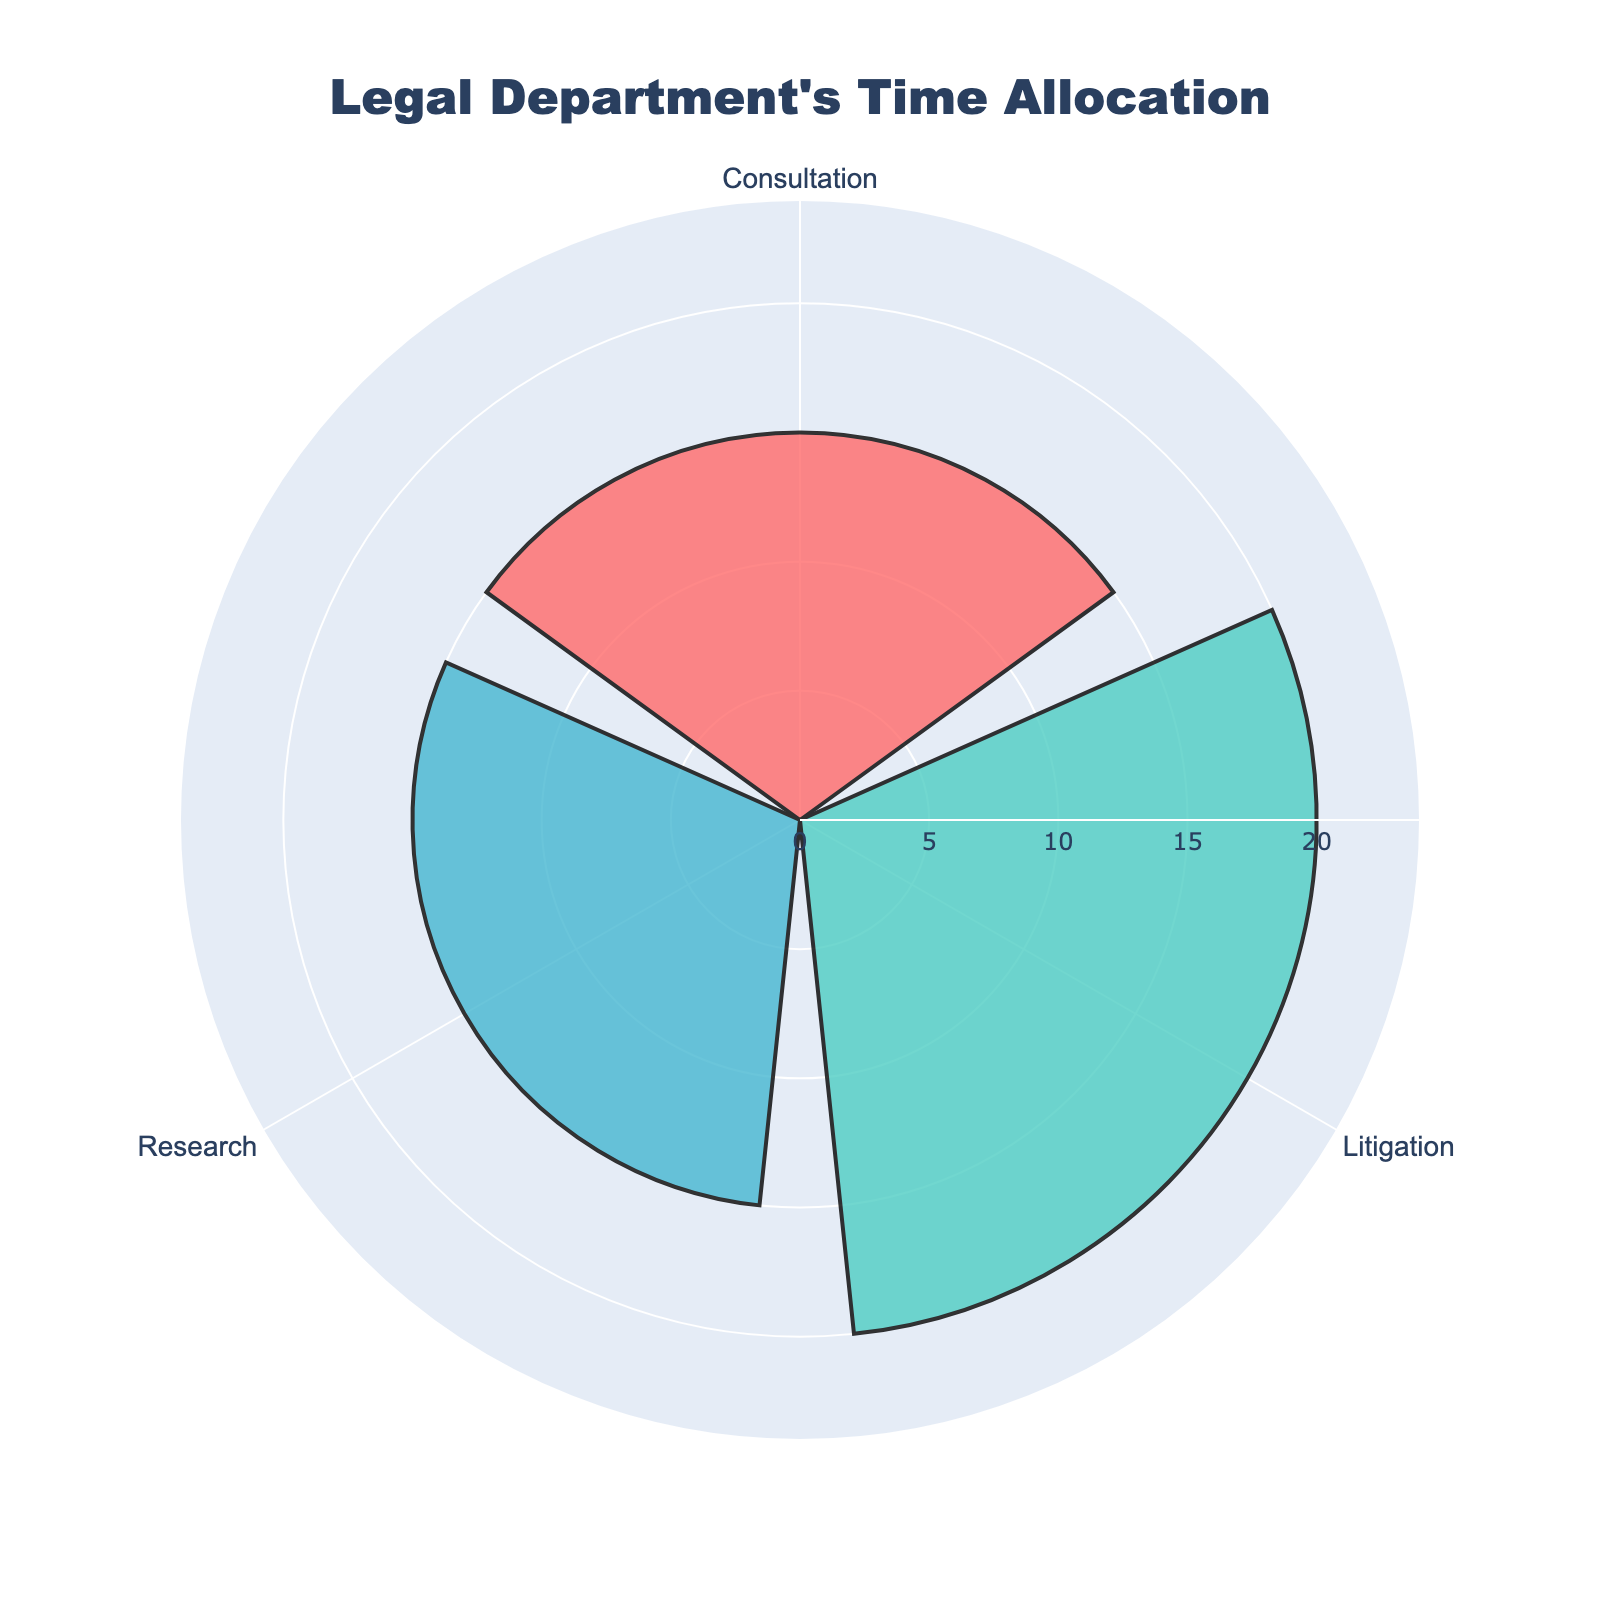What's the title of the figure? The title of the figure is prominently displayed at the top, directly above the rose chart.
Answer: Legal Department's Time Allocation How many activities are represented in the figure? Each activity is labeled around the chart, making the total number of activities easy to count.
Answer: 3 Which activity takes up the most time in a week? By comparing the lengths of the bars, you can see which one extends the furthest from the center. The longest bar represents the activity with the highest time allocation.
Answer: Litigation How much time is spent on Consultation per week? The "Consultation" bar represents the combined time from both types of consultations (10 + 5). Look at the length of the "Consultation" bar and find the number indicated on the radial axis.
Answer: 15 hours Compare the time spent on Research and Litigation. Which one is greater, and by how much? By comparing the lengths of the bars for "Research" and "Litigation," you can see which one is longer and then calculate the difference in their lengths.
Answer: Litigation is greater by 5 hours What is the total time allocated for all activities per week? Add the values of all bars: Research (15), Consultation (15), and Litigation (20).
Answer: 50 hours What percentage of the total time is spent on Research? First, find the total time (50 hours). Then calculate the percentage by dividing the time for Research (15 hours) by the total time and multiplying by 100.
Answer: 30% Is more time spent on Consultation or Research? Compare the lengths of the Consultation and Research bars to determine which one is longer.
Answer: Same amount Which activity has the shortest time allocation? Identify the bar that extends the least from the center of the chart.
Answer: Consultation Why might the Consultation time be divided into two separate activities originally? The original data distinguishes Consultation with the CEO and Consultation with Regulatory Bodies. This might reflect different types of interactions or purposes deemed important to track separately for legal reasons.
Answer: Different purposes of consultations 